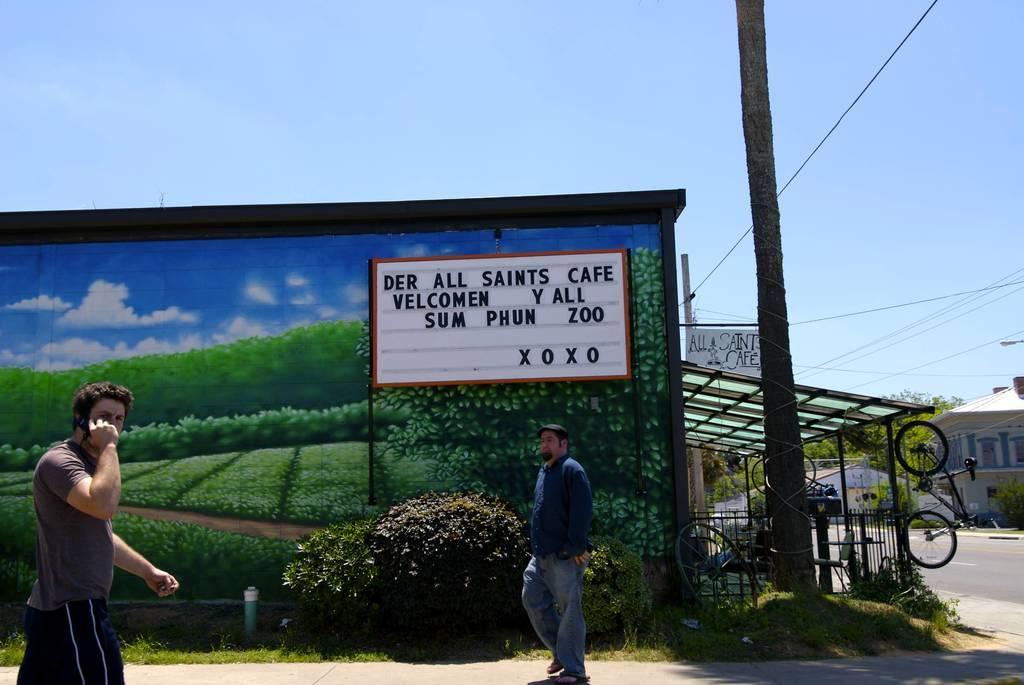Can you describe this image briefly? In this image I can see two persons walking on the road and at the top I can see the sky and in the middle I can see pole,power line cables ,fence and bicycles, hoarding board. On the hoarding board I can see image of greenery,text and the sky, on the right side I can see house and trees. 